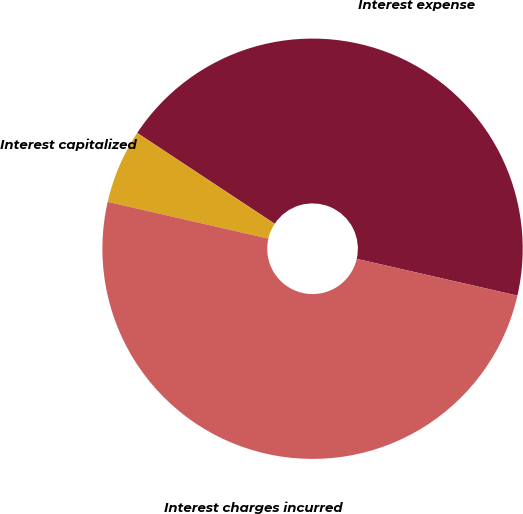<chart> <loc_0><loc_0><loc_500><loc_500><pie_chart><fcel>Interest expense<fcel>Interest capitalized<fcel>Interest charges incurred<nl><fcel>44.29%<fcel>5.71%<fcel>50.0%<nl></chart> 